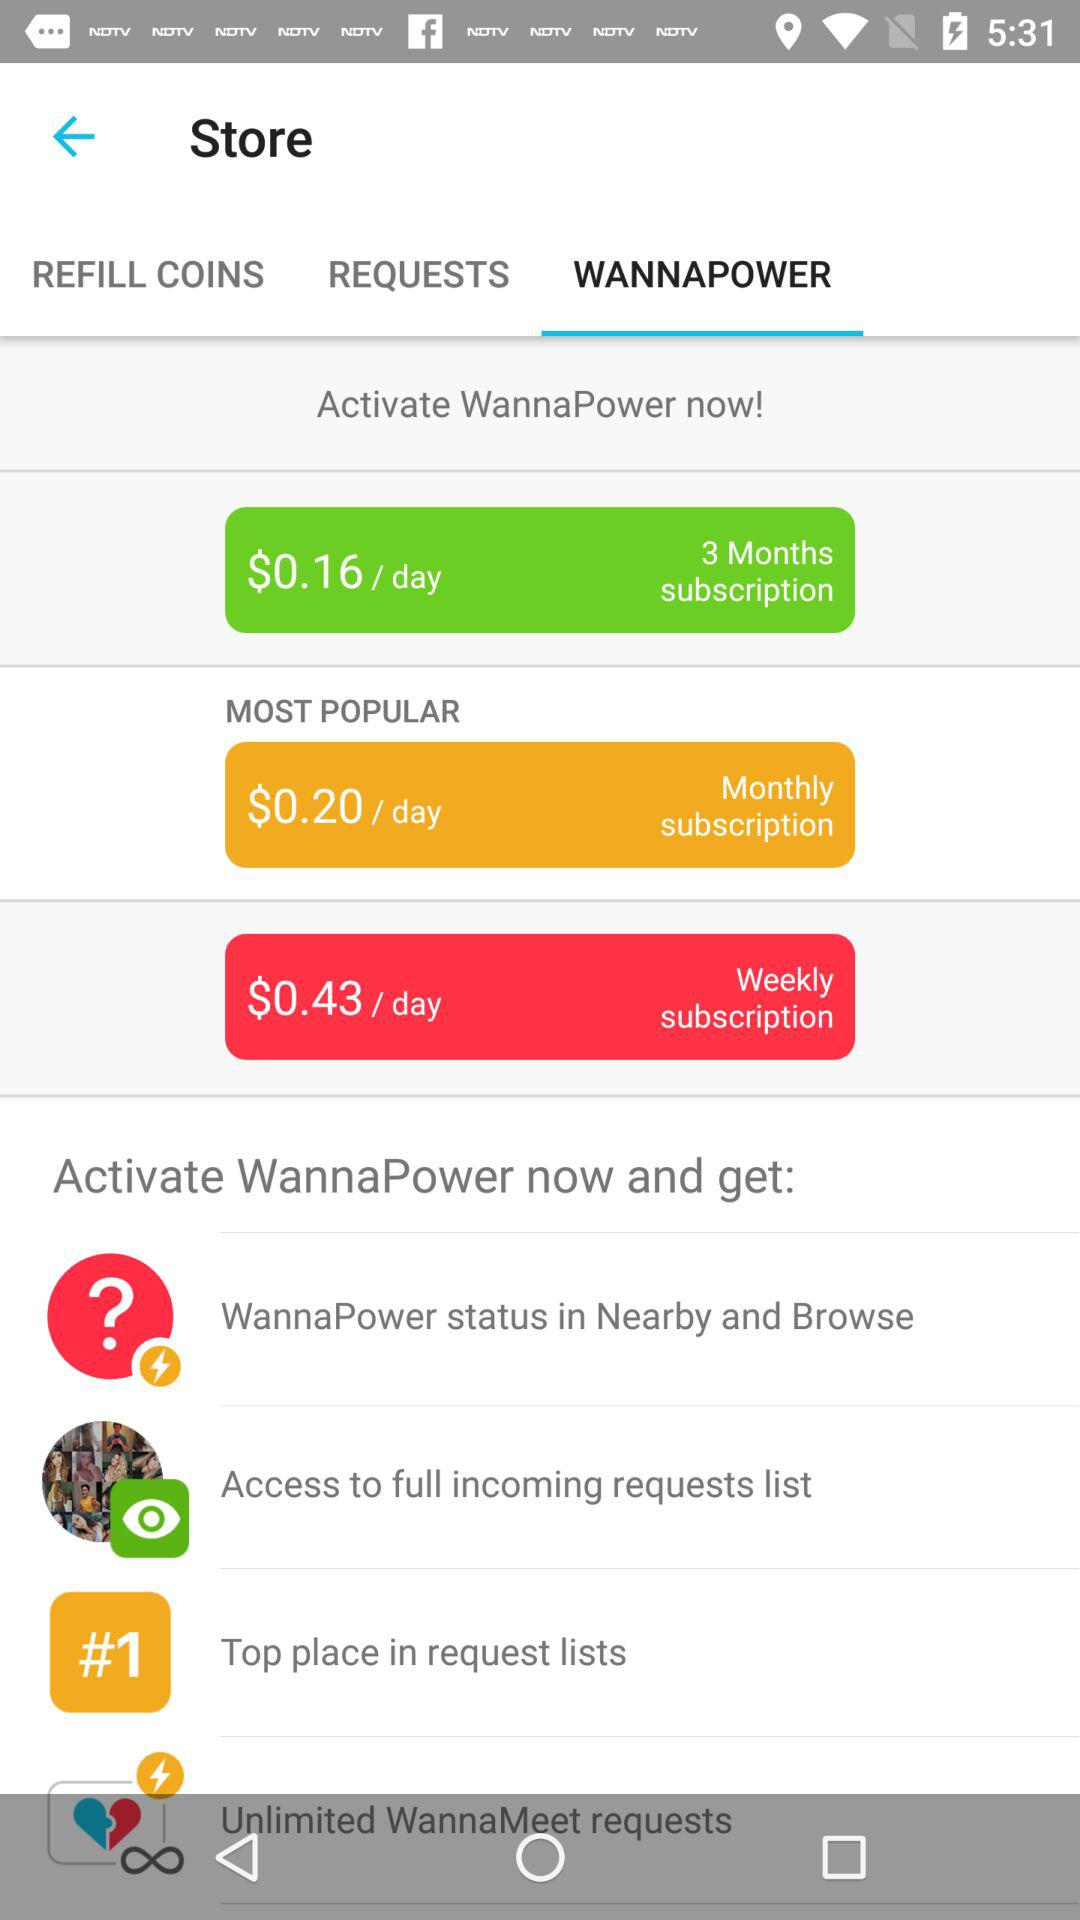What tab has been selected? The tab that has been selected is "WANNAPOWER". 